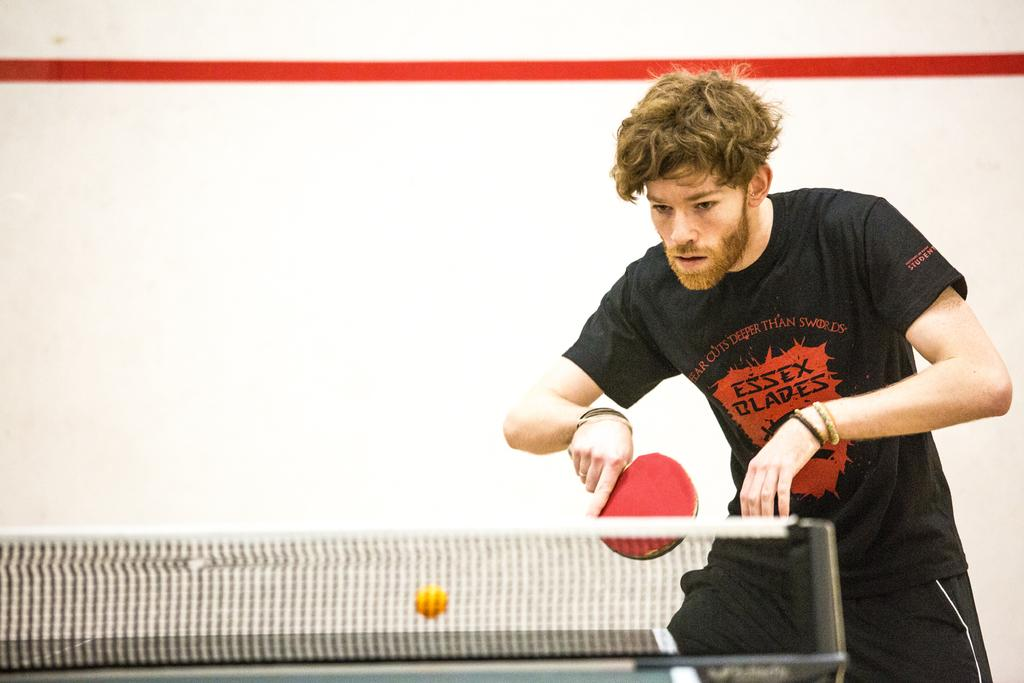Who is the main subject in the image? There is a boy in the image. Where is the boy located in the image? The boy is on the right side of the image. What is the net used for in the image? The net is used for playing table tennis in the image. What is the table used for in the image? The table is used for playing table tennis in the image. What sport is the boy playing in the image? The boy is playing table tennis in the image. Can you hear the sound of a spoon clinking against a glass in the image? There is no sound present in the image, and no spoon or glass is visible. 